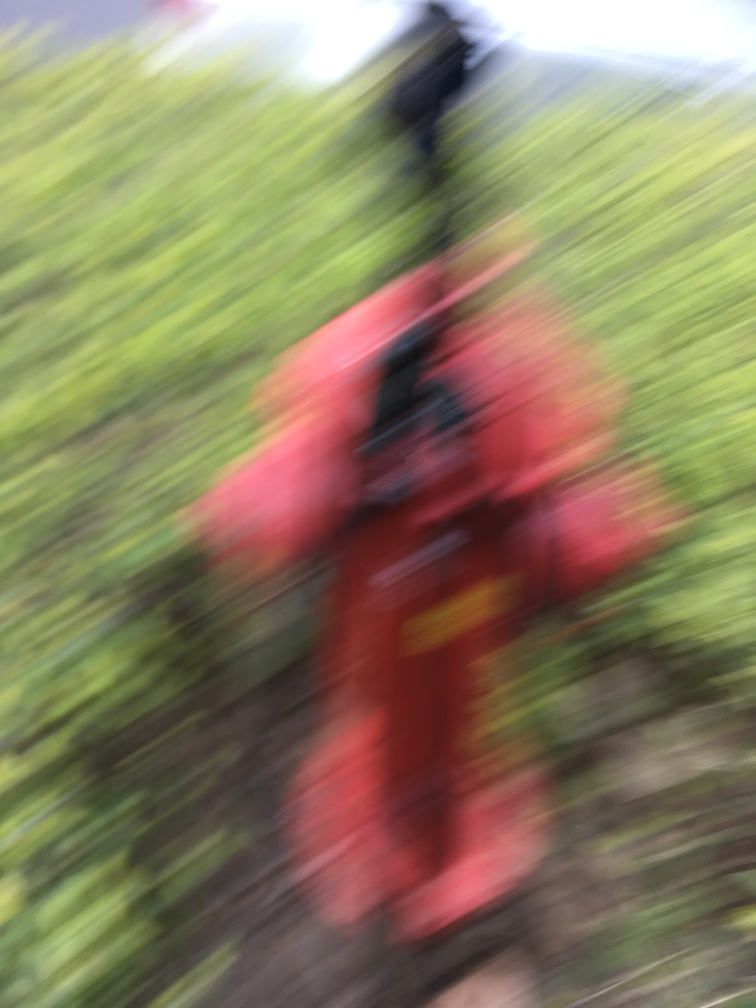Could you suggest how to improve a similar image in the future? Certainly! To improve sharpness in future photos, one could use a faster shutter speed to minimize the effects of camera shake. It's also beneficial to ensure the camera's focus is set accurately on the subject, and using a tripod or stabilizer can help avoid unintended movement. Additionally, increasing the lighting or using the camera's flash, if conditions are dim, can help the camera capture a crisper image. 